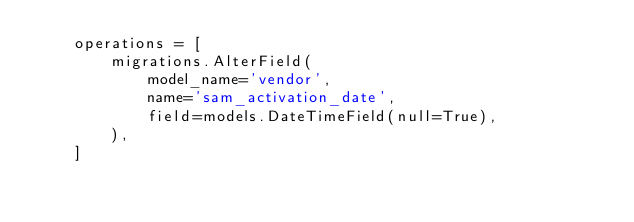<code> <loc_0><loc_0><loc_500><loc_500><_Python_>    operations = [
        migrations.AlterField(
            model_name='vendor',
            name='sam_activation_date',
            field=models.DateTimeField(null=True),
        ),
    ]
</code> 